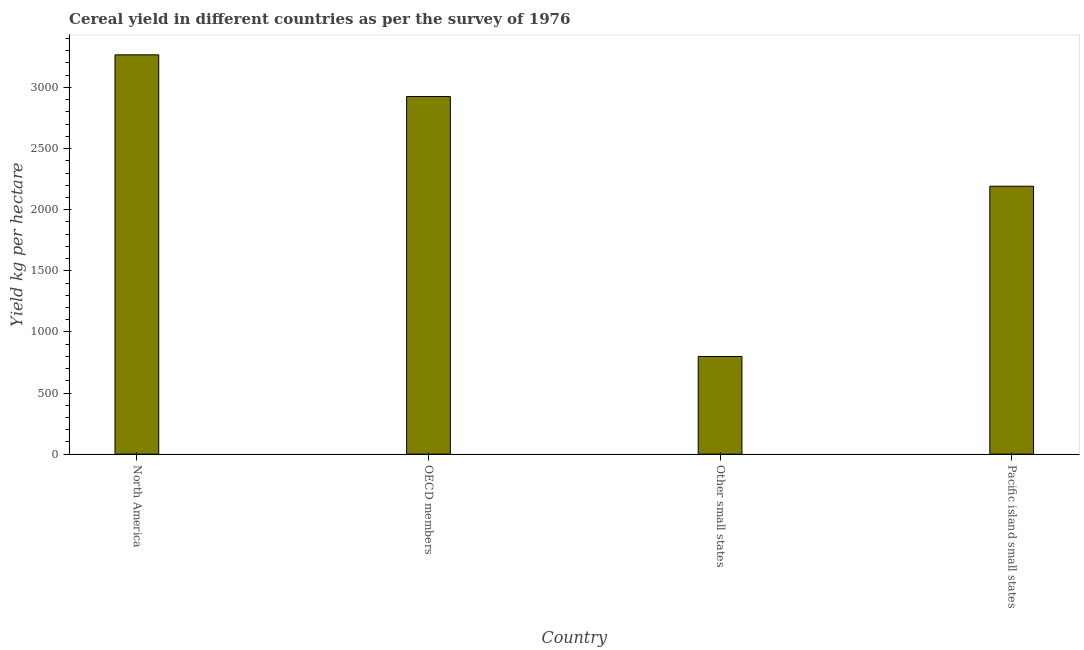What is the title of the graph?
Your response must be concise. Cereal yield in different countries as per the survey of 1976. What is the label or title of the X-axis?
Make the answer very short. Country. What is the label or title of the Y-axis?
Keep it short and to the point. Yield kg per hectare. What is the cereal yield in North America?
Your answer should be compact. 3266.63. Across all countries, what is the maximum cereal yield?
Offer a very short reply. 3266.63. Across all countries, what is the minimum cereal yield?
Make the answer very short. 798.95. In which country was the cereal yield maximum?
Provide a succinct answer. North America. In which country was the cereal yield minimum?
Provide a succinct answer. Other small states. What is the sum of the cereal yield?
Your response must be concise. 9182.78. What is the difference between the cereal yield in North America and OECD members?
Ensure brevity in your answer.  341.1. What is the average cereal yield per country?
Make the answer very short. 2295.7. What is the median cereal yield?
Give a very brief answer. 2558.6. In how many countries, is the cereal yield greater than 200 kg per hectare?
Your response must be concise. 4. What is the ratio of the cereal yield in North America to that in Pacific island small states?
Keep it short and to the point. 1.49. Is the cereal yield in OECD members less than that in Other small states?
Provide a short and direct response. No. Is the difference between the cereal yield in North America and OECD members greater than the difference between any two countries?
Your answer should be compact. No. What is the difference between the highest and the second highest cereal yield?
Provide a succinct answer. 341.1. Is the sum of the cereal yield in North America and OECD members greater than the maximum cereal yield across all countries?
Provide a short and direct response. Yes. What is the difference between the highest and the lowest cereal yield?
Your answer should be compact. 2467.68. Are all the bars in the graph horizontal?
Offer a terse response. No. How many countries are there in the graph?
Keep it short and to the point. 4. Are the values on the major ticks of Y-axis written in scientific E-notation?
Make the answer very short. No. What is the Yield kg per hectare of North America?
Offer a terse response. 3266.63. What is the Yield kg per hectare of OECD members?
Your answer should be compact. 2925.53. What is the Yield kg per hectare in Other small states?
Offer a terse response. 798.95. What is the Yield kg per hectare in Pacific island small states?
Keep it short and to the point. 2191.67. What is the difference between the Yield kg per hectare in North America and OECD members?
Your answer should be compact. 341.1. What is the difference between the Yield kg per hectare in North America and Other small states?
Your answer should be compact. 2467.68. What is the difference between the Yield kg per hectare in North America and Pacific island small states?
Ensure brevity in your answer.  1074.96. What is the difference between the Yield kg per hectare in OECD members and Other small states?
Provide a short and direct response. 2126.57. What is the difference between the Yield kg per hectare in OECD members and Pacific island small states?
Keep it short and to the point. 733.86. What is the difference between the Yield kg per hectare in Other small states and Pacific island small states?
Make the answer very short. -1392.71. What is the ratio of the Yield kg per hectare in North America to that in OECD members?
Your answer should be very brief. 1.12. What is the ratio of the Yield kg per hectare in North America to that in Other small states?
Offer a very short reply. 4.09. What is the ratio of the Yield kg per hectare in North America to that in Pacific island small states?
Your response must be concise. 1.49. What is the ratio of the Yield kg per hectare in OECD members to that in Other small states?
Your answer should be compact. 3.66. What is the ratio of the Yield kg per hectare in OECD members to that in Pacific island small states?
Make the answer very short. 1.33. What is the ratio of the Yield kg per hectare in Other small states to that in Pacific island small states?
Ensure brevity in your answer.  0.36. 